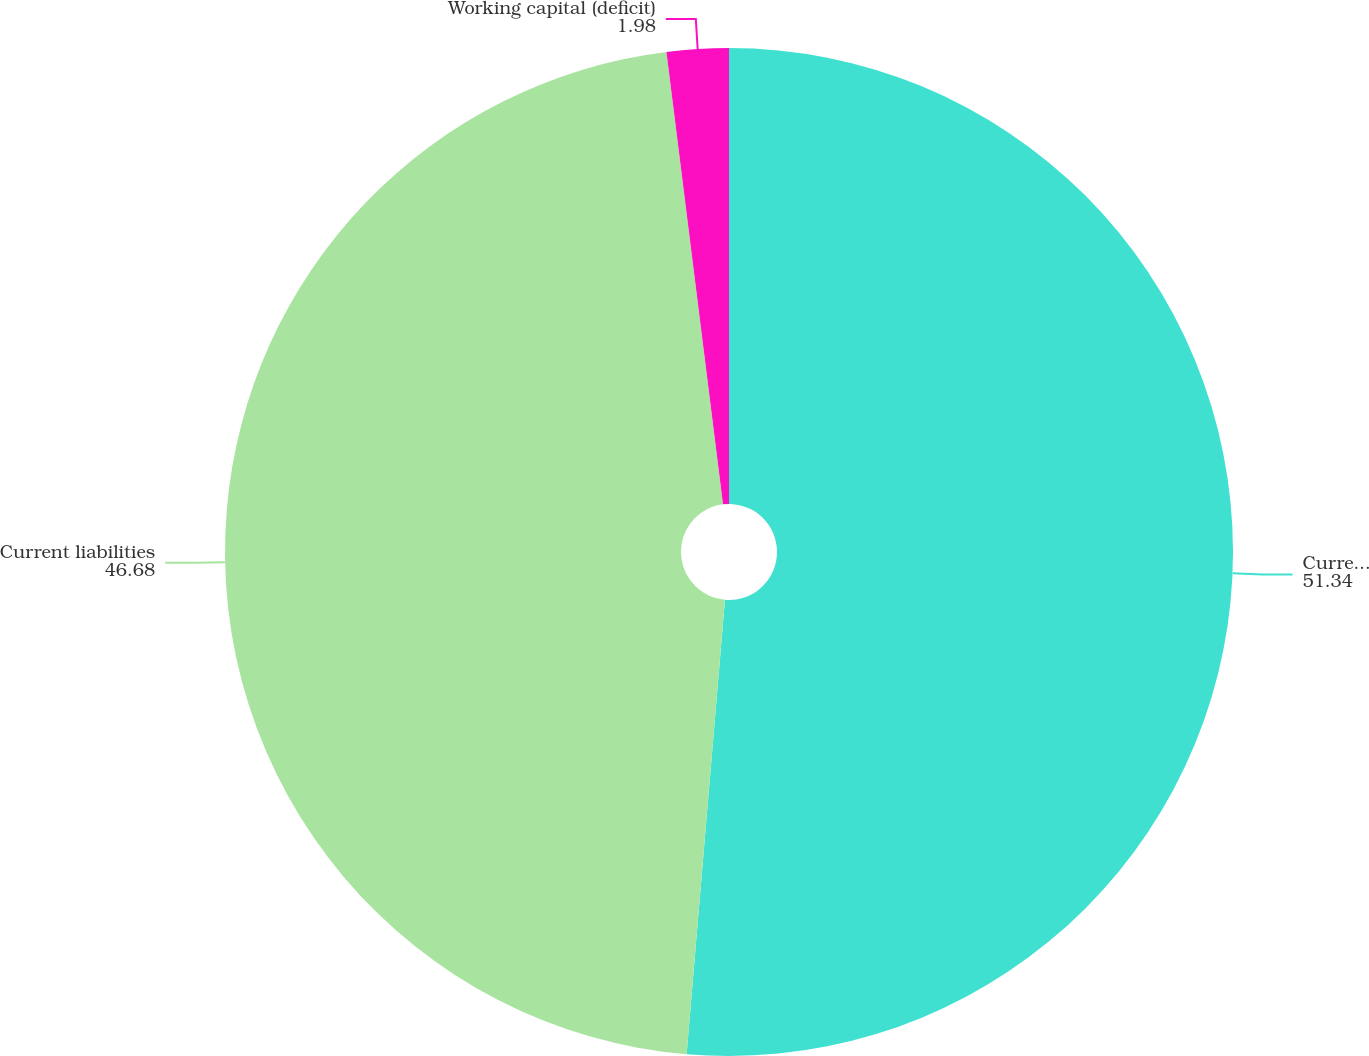Convert chart to OTSL. <chart><loc_0><loc_0><loc_500><loc_500><pie_chart><fcel>Current assets<fcel>Current liabilities<fcel>Working capital (deficit)<nl><fcel>51.34%<fcel>46.68%<fcel>1.98%<nl></chart> 